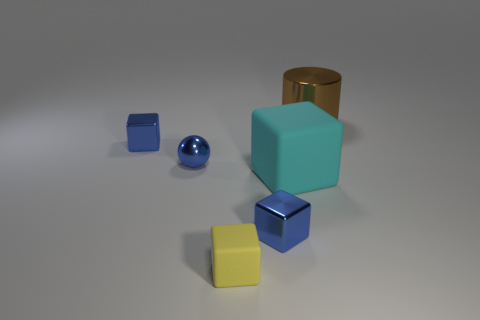Is the number of objects to the right of the yellow block the same as the number of metallic objects right of the big cyan matte object?
Offer a terse response. No. Is the number of tiny cubes that are behind the cyan object greater than the number of tiny blue rubber cylinders?
Your answer should be compact. Yes. How many objects are small blue objects that are behind the big cyan matte cube or tiny purple metal balls?
Your response must be concise. 2. How many big cylinders have the same material as the big cube?
Provide a succinct answer. 0. Are there any other things of the same shape as the tiny yellow object?
Offer a terse response. Yes. There is a brown metallic object that is the same size as the cyan rubber block; what is its shape?
Give a very brief answer. Cylinder. There is a small sphere; is its color the same as the small metal thing behind the blue metal ball?
Provide a succinct answer. Yes. What number of objects are in front of the tiny blue metallic block in front of the blue ball?
Your answer should be very brief. 1. There is a metallic object that is both in front of the big brown cylinder and to the right of the tiny matte cube; what is its size?
Provide a short and direct response. Small. Is there a cyan matte cube that has the same size as the brown metal cylinder?
Offer a very short reply. Yes. 